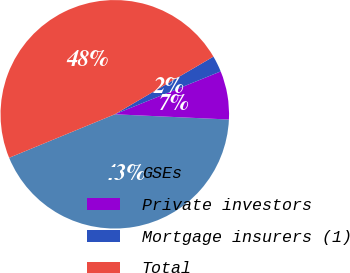Convert chart to OTSL. <chart><loc_0><loc_0><loc_500><loc_500><pie_chart><fcel>GSEs<fcel>Private investors<fcel>Mortgage insurers (1)<fcel>Total<nl><fcel>43.06%<fcel>6.85%<fcel>2.3%<fcel>47.8%<nl></chart> 